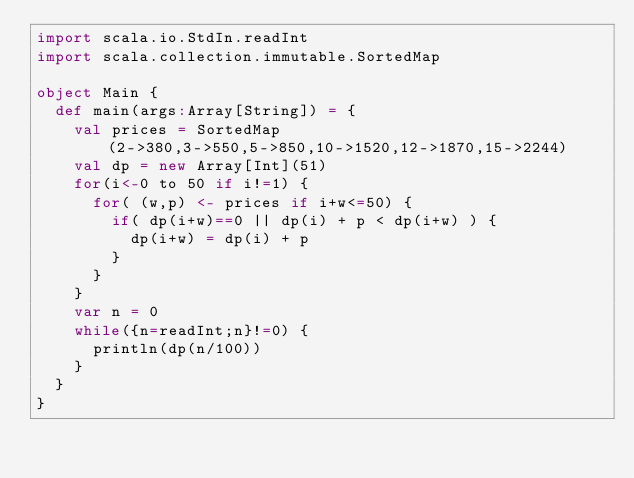<code> <loc_0><loc_0><loc_500><loc_500><_Scala_>import scala.io.StdIn.readInt
import scala.collection.immutable.SortedMap

object Main {
  def main(args:Array[String]) = {
    val prices = SortedMap(2->380,3->550,5->850,10->1520,12->1870,15->2244)
    val dp = new Array[Int](51)
    for(i<-0 to 50 if i!=1) {
      for( (w,p) <- prices if i+w<=50) {
        if( dp(i+w)==0 || dp(i) + p < dp(i+w) ) {
          dp(i+w) = dp(i) + p
        }
      }
    }
    var n = 0
    while({n=readInt;n}!=0) {
      println(dp(n/100))
    }
  }
}</code> 